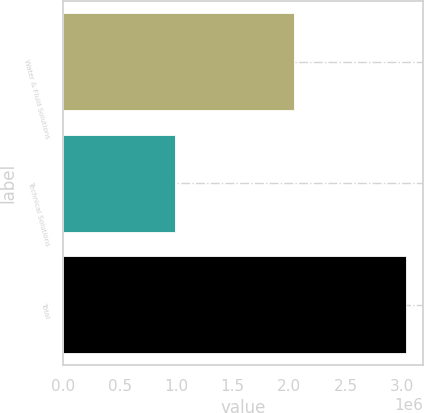Convert chart. <chart><loc_0><loc_0><loc_500><loc_500><bar_chart><fcel>Water & Fluid Solutions<fcel>Technical Solutions<fcel>Total<nl><fcel>2.04128e+06<fcel>989492<fcel>3.03077e+06<nl></chart> 